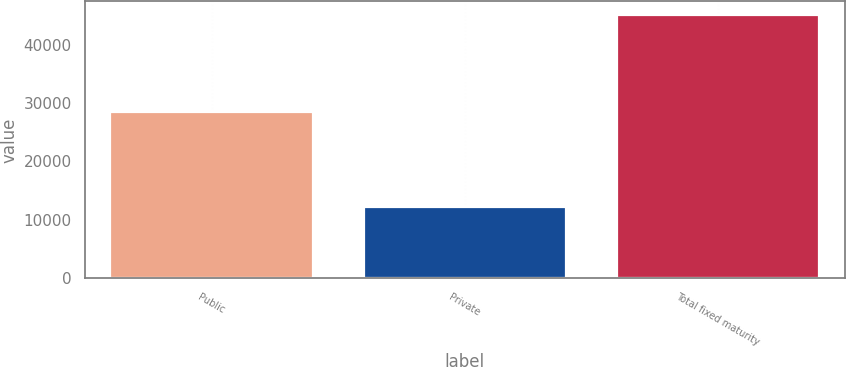Convert chart to OTSL. <chart><loc_0><loc_0><loc_500><loc_500><bar_chart><fcel>Public<fcel>Private<fcel>Total fixed maturity<nl><fcel>28439.8<fcel>12159.7<fcel>45111.8<nl></chart> 